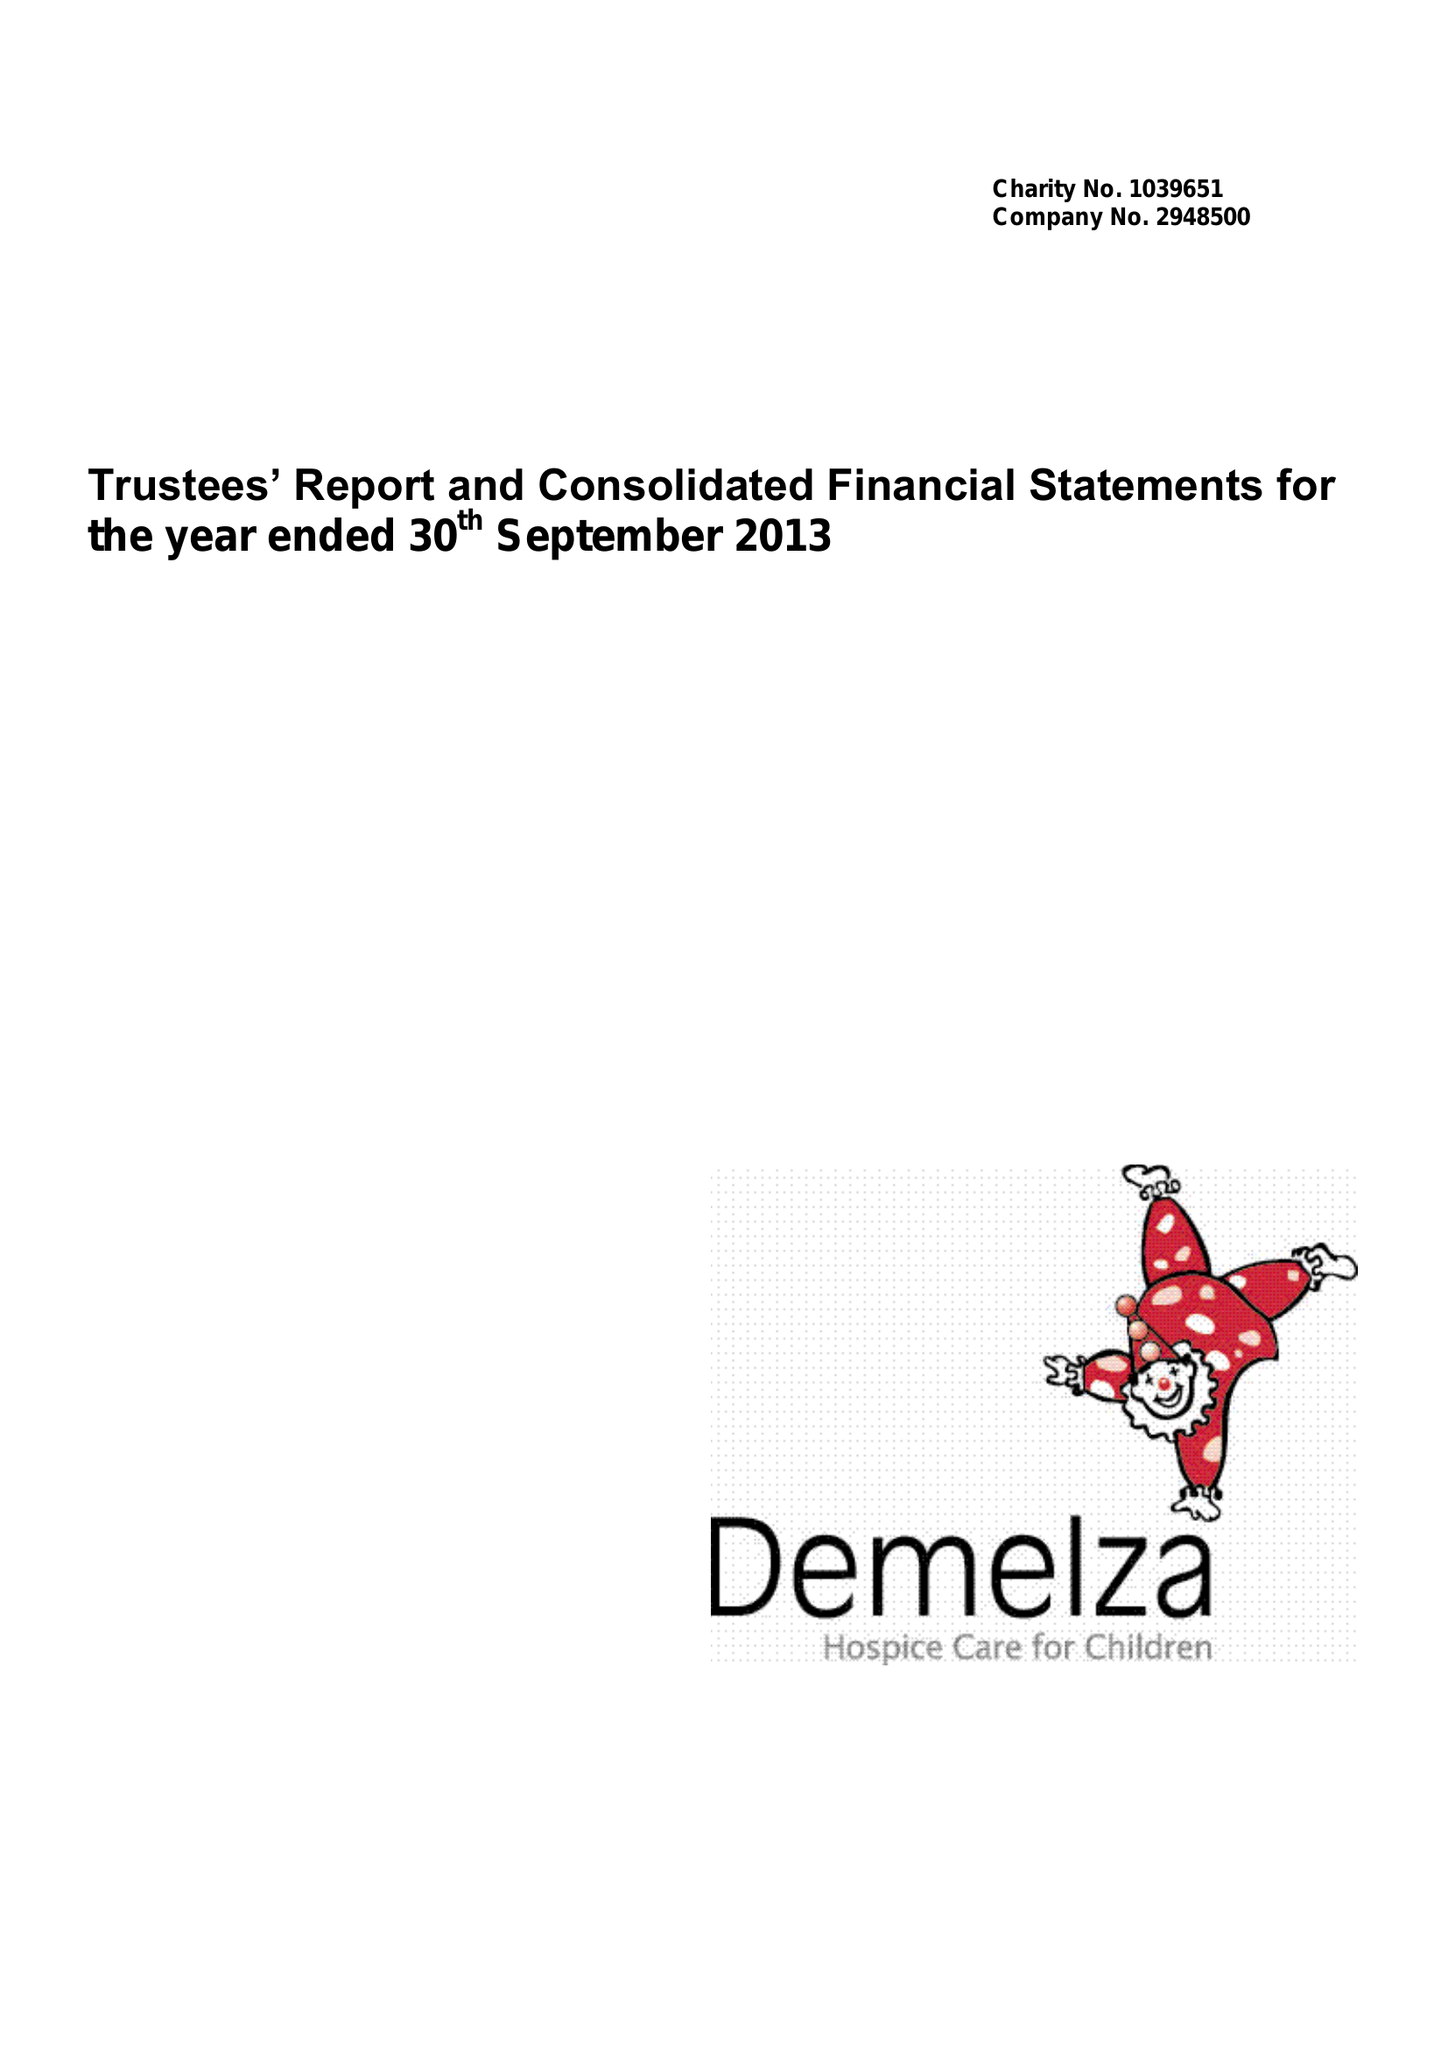What is the value for the charity_name?
Answer the question using a single word or phrase. Demelza House Childrens Hospice 